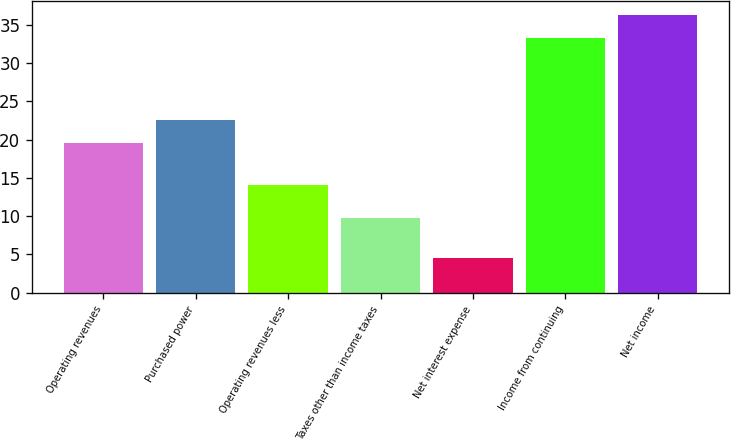<chart> <loc_0><loc_0><loc_500><loc_500><bar_chart><fcel>Operating revenues<fcel>Purchased power<fcel>Operating revenues less<fcel>Taxes other than income taxes<fcel>Net interest expense<fcel>Income from continuing<fcel>Net income<nl><fcel>19.6<fcel>22.54<fcel>14.1<fcel>9.7<fcel>4.5<fcel>33.3<fcel>36.24<nl></chart> 